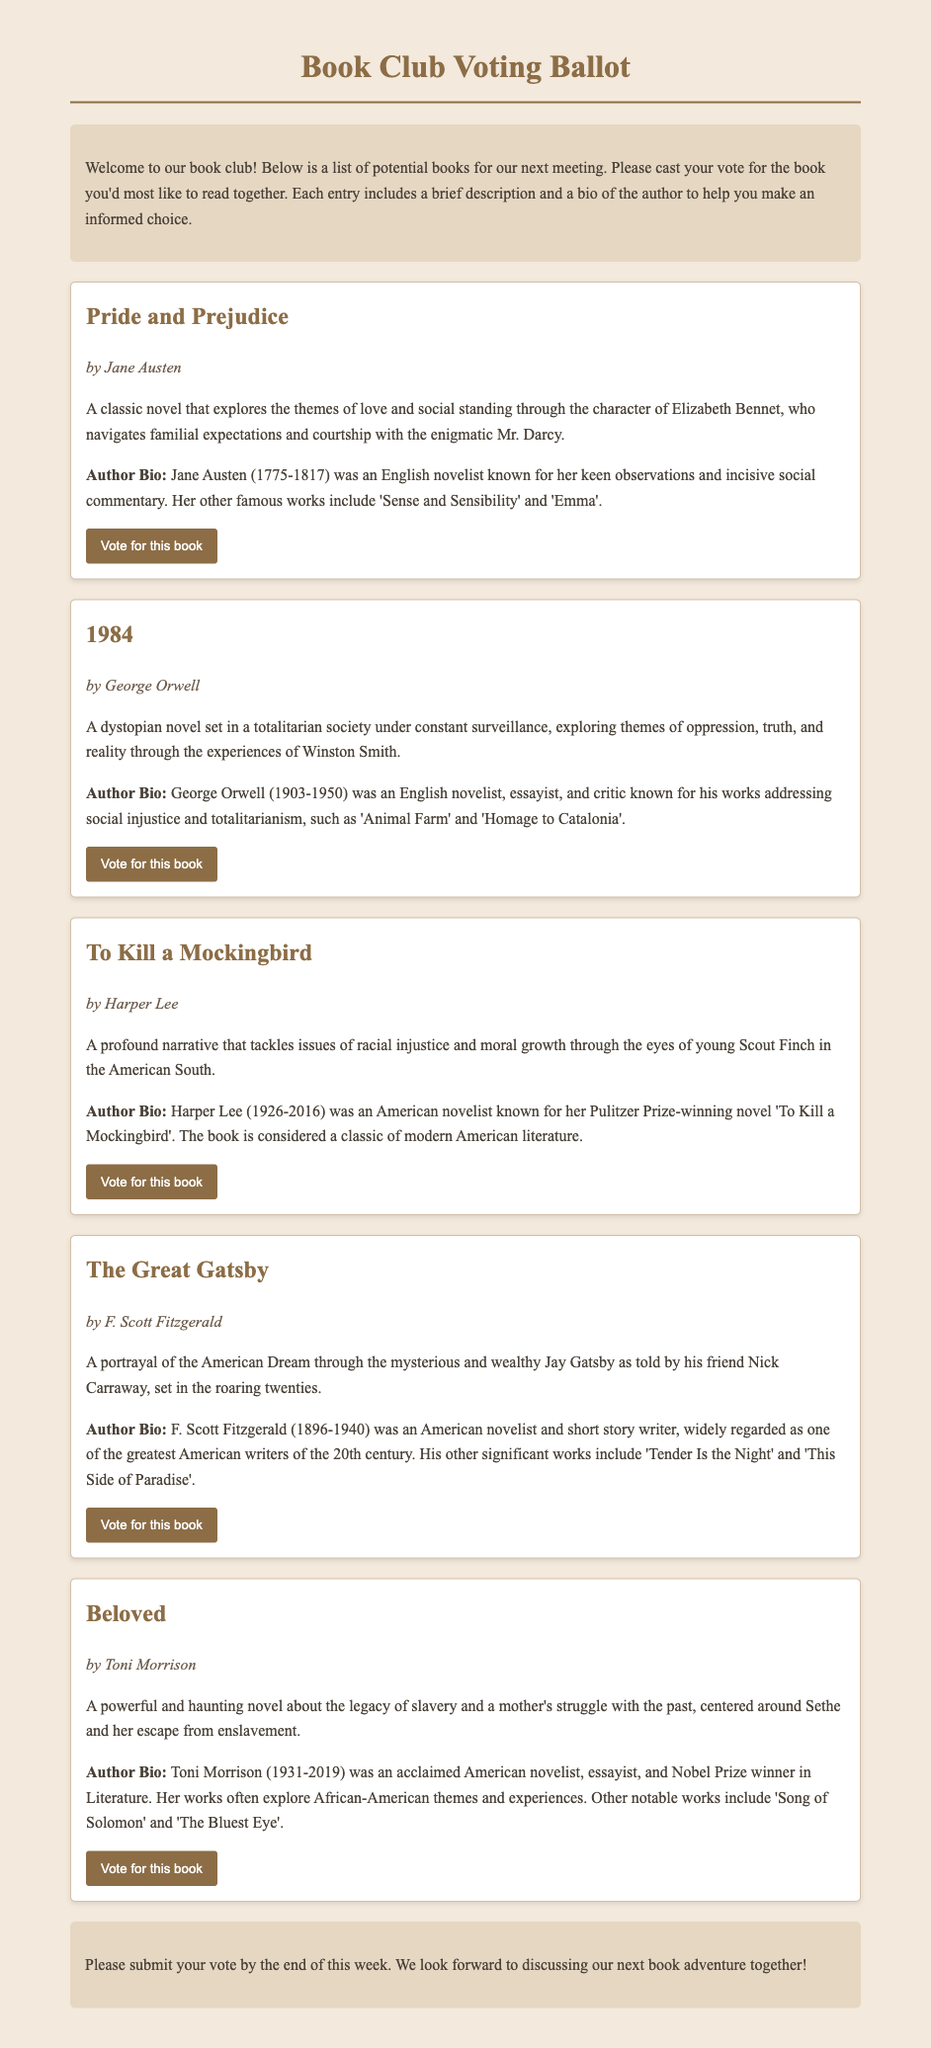what is the title of the first book listed? The first book mentioned in the ballot is "Pride and Prejudice."
Answer: Pride and Prejudice who is the author of "1984"? The author of "1984" is George Orwell.
Answer: George Orwell what central theme does "To Kill a Mockingbird" explore? The central theme explored in "To Kill a Mockingbird" is racial injustice.
Answer: racial injustice how many books are included in the ballot? There are five books included in the ballot for voting.
Answer: five which author is known for the work "Beloved"? The author known for "Beloved" is Toni Morrison.
Answer: Toni Morrison what year was Jane Austen born? Jane Austen was born in 1775.
Answer: 1775 what is the main setting period of "The Great Gatsby"? "The Great Gatsby" is primarily set in the roaring twenties.
Answer: roaring twenties who received the Nobel Prize in Literature? Toni Morrison received the Nobel Prize in Literature.
Answer: Toni Morrison what is the last date for submitting votes? The document states that votes should be submitted by the end of this week.
Answer: end of this week 